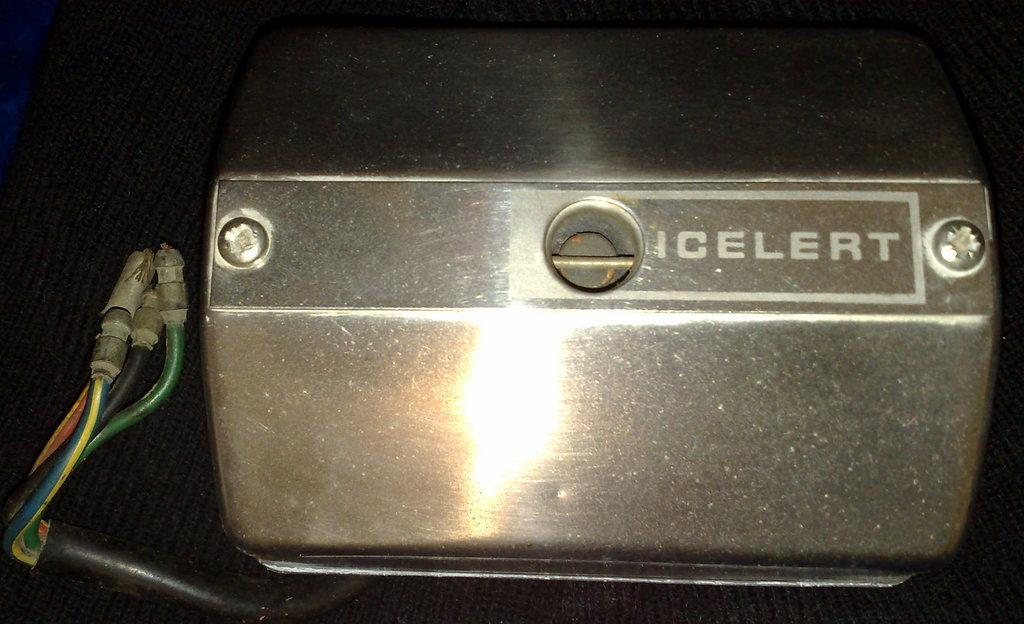What type of fasteners are visible in the image? There are screws in the image. What are the screws attached to? The screws are attached to a metal box. What else can be seen in the image besides the screws and metal box? There are cables in the image. How are the objects in the image arranged? The objects are placed on a black cloth. Can you see any horses or blood in the image? No, there are no horses or blood present in the image. Is there any grain visible in the image? No, there is no grain visible in the image. 